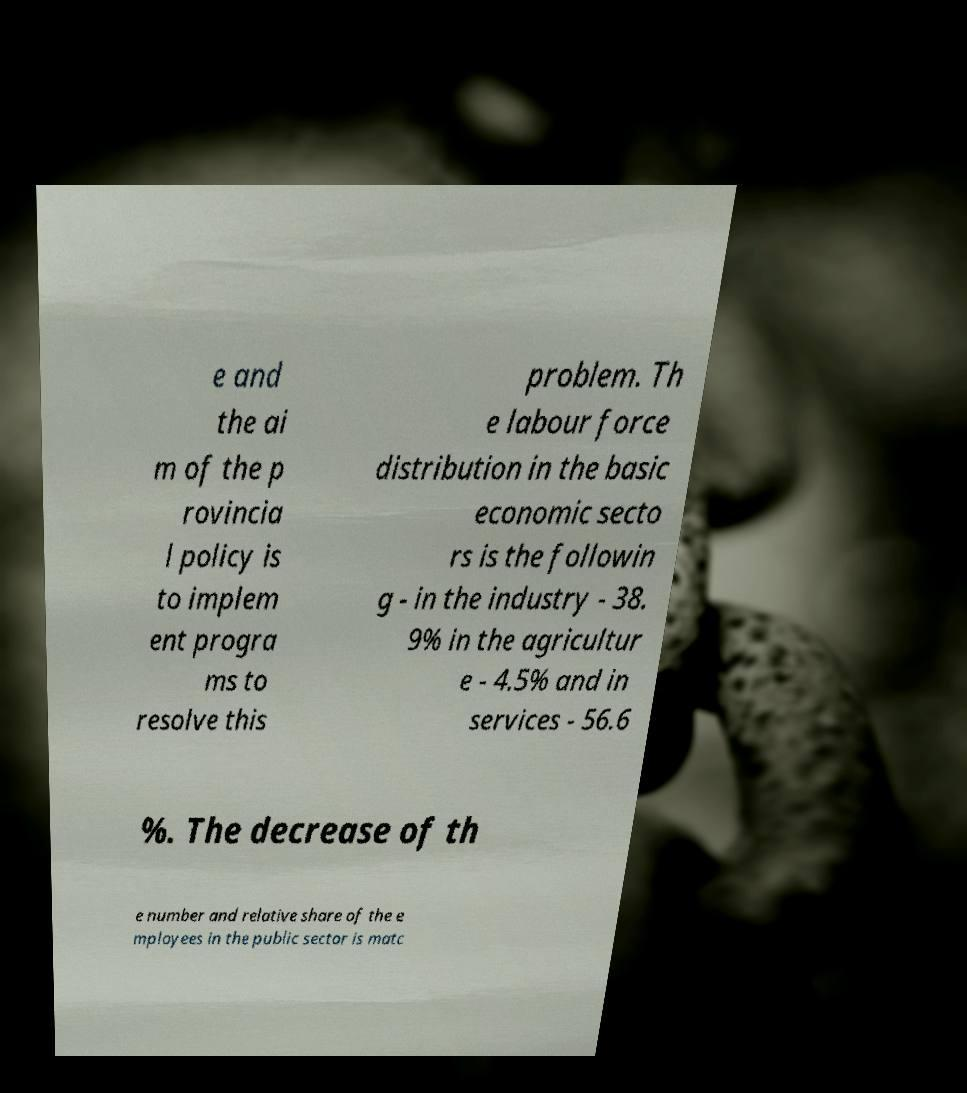Could you extract and type out the text from this image? e and the ai m of the p rovincia l policy is to implem ent progra ms to resolve this problem. Th e labour force distribution in the basic economic secto rs is the followin g - in the industry - 38. 9% in the agricultur e - 4.5% and in services - 56.6 %. The decrease of th e number and relative share of the e mployees in the public sector is matc 